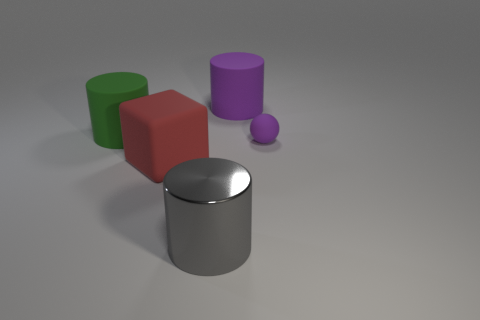Is there any other thing that has the same material as the gray object?
Give a very brief answer. No. There is a thing that is the same color as the tiny ball; what shape is it?
Provide a succinct answer. Cylinder. Do the purple thing that is on the left side of the tiny matte ball and the large red block have the same material?
Make the answer very short. Yes. How many large objects are either yellow cylinders or purple matte cylinders?
Offer a very short reply. 1. What is the size of the sphere?
Keep it short and to the point. Small. There is a gray metallic cylinder; is it the same size as the purple matte object that is behind the tiny ball?
Provide a short and direct response. Yes. How many brown objects are cubes or large things?
Make the answer very short. 0. What number of red objects are there?
Offer a very short reply. 1. What is the size of the purple thing that is in front of the green matte cylinder?
Ensure brevity in your answer.  Small. Does the purple rubber ball have the same size as the green thing?
Make the answer very short. No. 